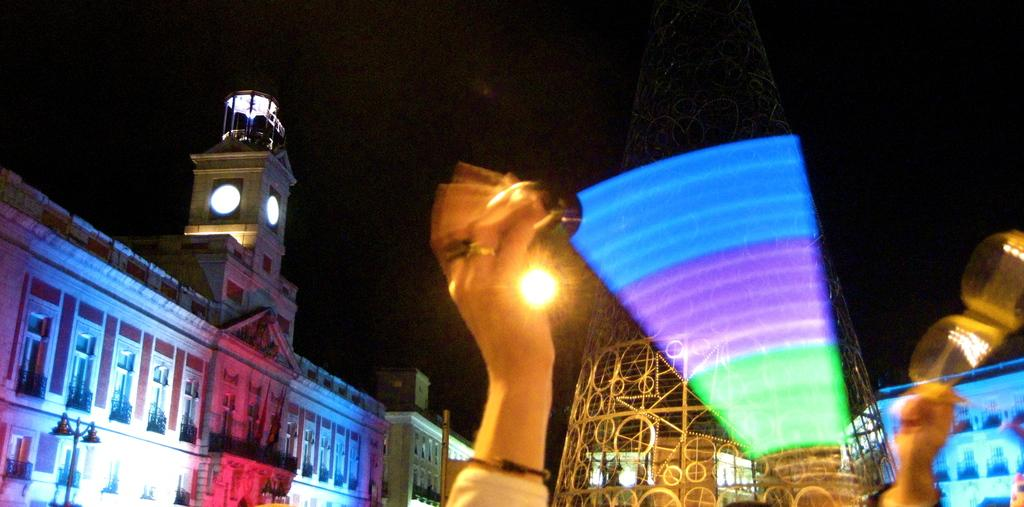What type of structures can be seen in the background of the image? There are buildings in the background of the image. What part of a person can be seen in the image? The hands of a person are visible in the image. What is the prominent feature with lights in the image? There is a tower with lights in the image. What time of day was the image taken? The image was taken at night time. What is the price of the tower with lights in the image? The image does not provide any information about the price of the tower with lights. How does the daughter feel about the tower with lights in the image? There is no mention of a daughter in the image, so we cannot determine her feelings about the tower with lights. 